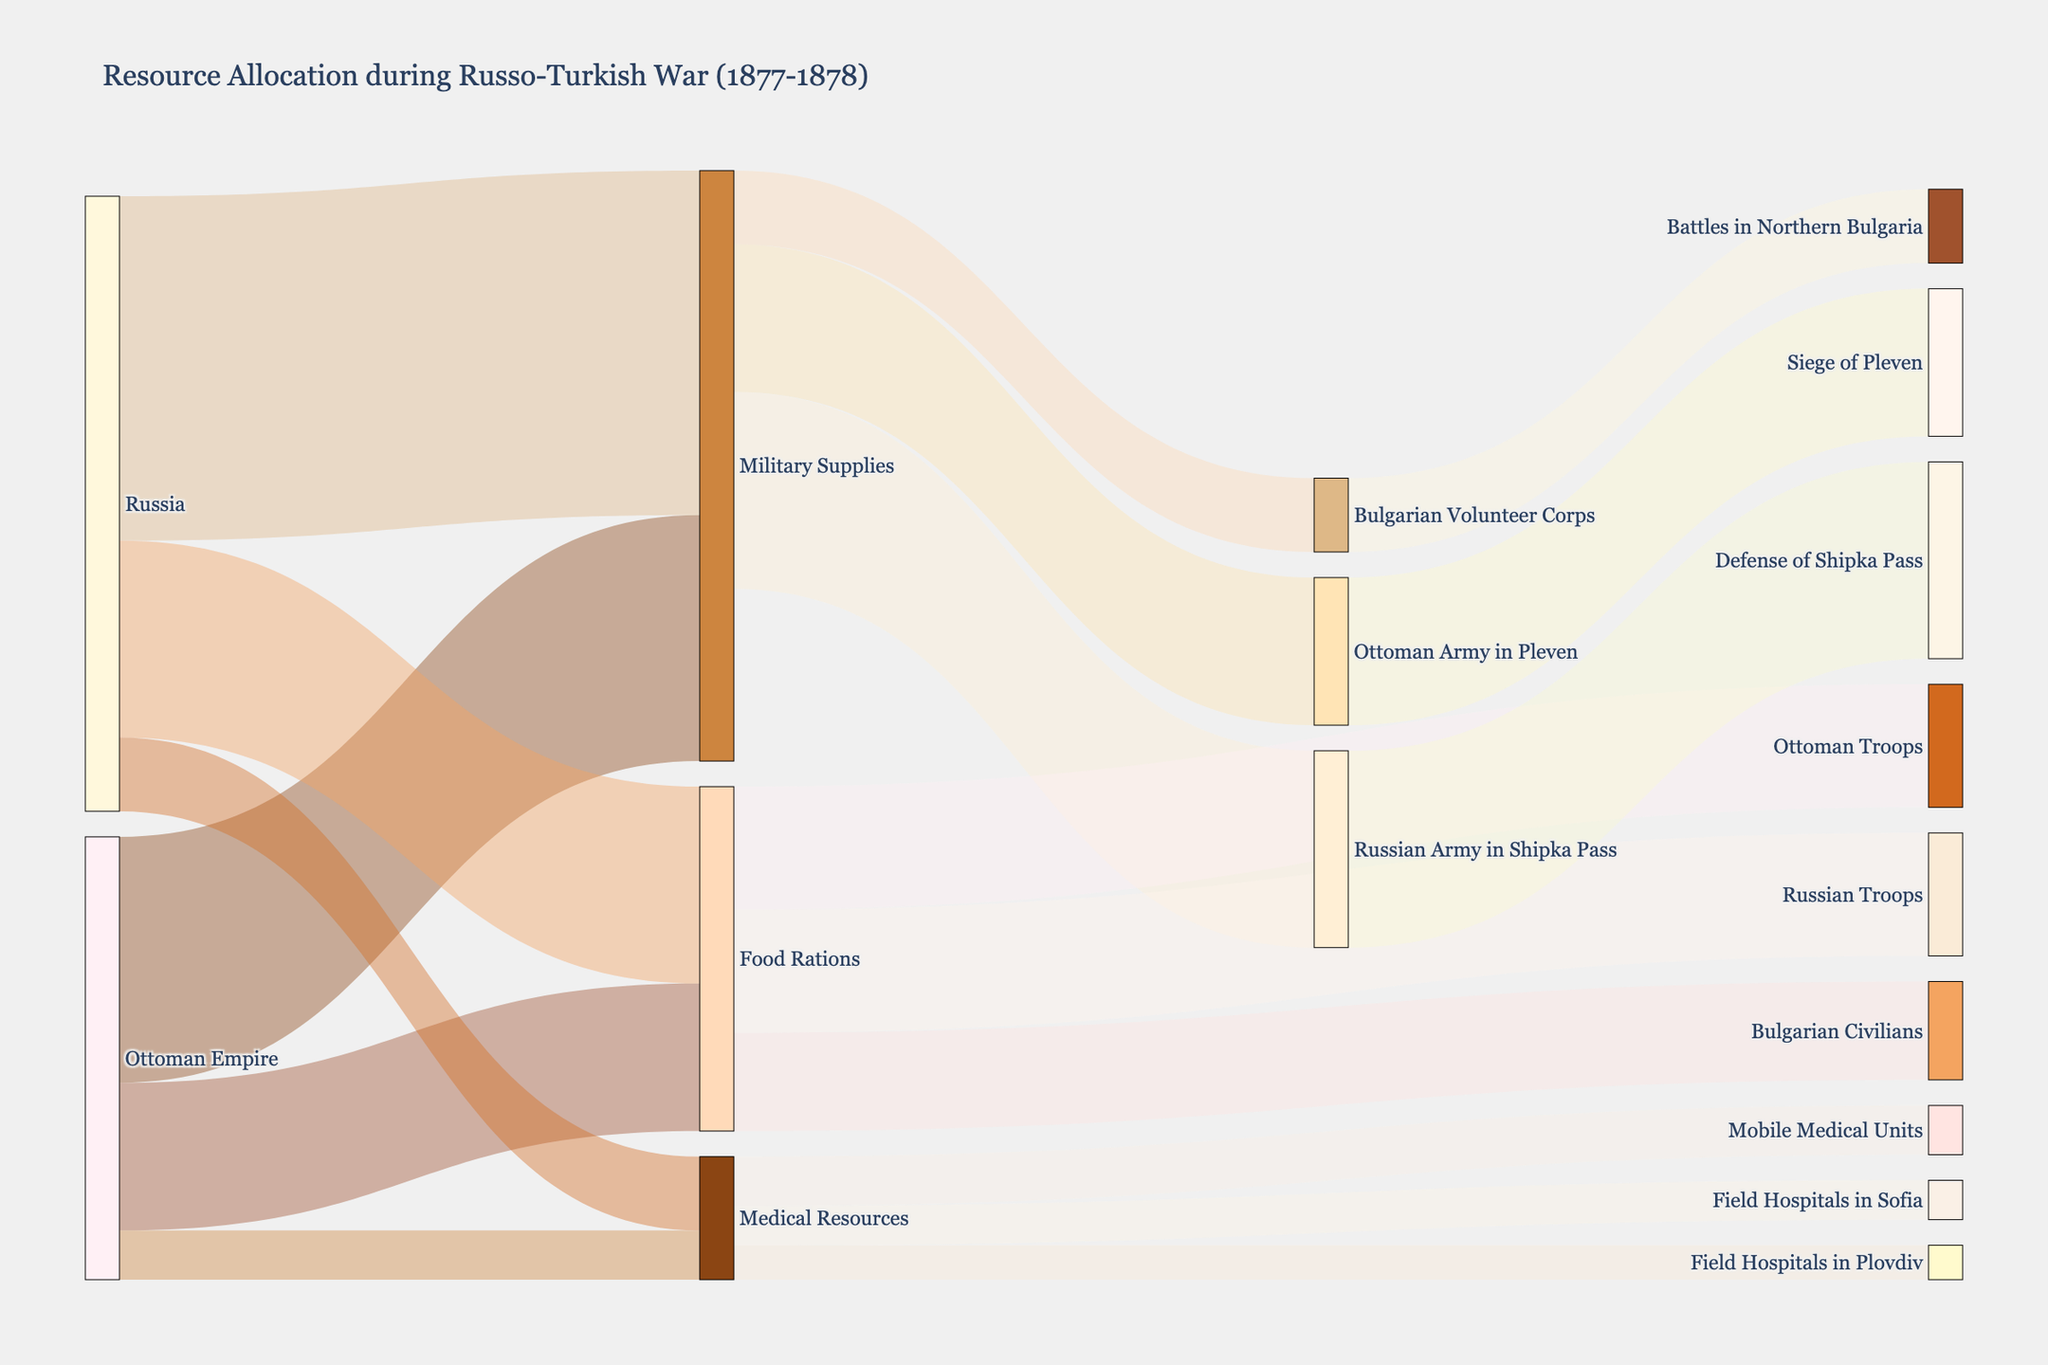What is the total amount of Military Supplies allocated by both the Ottoman Empire and Russia? Sum the value of Military Supplies from both the Ottoman Empire (50,000) and Russia (70,000): 50,000 + 70,000 = 120,000
Answer: 120,000 Which country allocated more Food Rations, and by how much? Compare the Food Rations allocated by the Ottoman Empire (30,000) and Russia (40,000); Russia allocated 40,000 - 30,000 = 10,000 more
Answer: Russia, 10,000 more How much Medical Resources were provided to the Field Hospitals in Bulgaria (Sofia and Plovdiv combined)? Add the Medical Resources values for Sofia (8,000) and Plovdiv (7,000): 8,000 + 7,000 = 15,000
Answer: 15,000 What were the primary destinations for the Military Supplies provided by the Ottoman Empire and Russia? The primary destinations for Military Supplies are the Bulgarian Volunteer Corps (15,000), the Ottoman Army in Pleven (30,000), and the Russian Army in Shipka Pass (40,000) as per their respective contributions
Answer: Bulgarian Volunteer Corps, Ottoman Army in Pleven, Russian Army in Shipka Pass Compare the amount of Military Supplies allocated to the Ottoman Army in Pleven and the Russian Army in Shipka Pass. Which received more and by what margin? The Ottoman Army in Pleven received 30,000 while the Russian Army in Shipka Pass received 40,000; the Russian Army received 40,000 - 30,000 = 10,000 more
Answer: Russian Army, 10,000 more How much Medical Resources were allocated to Mobile Medical Units? The figure shows that Mobile Medical Units received 10,000 in Medical Resources
Answer: 10,000 What was the distribution of Food Rations to military and civilian populations, and which received more? Food Rations were allocated as follows: Bulgarian Civilians (20,000), Ottoman Troops (25,000), Russian Troops (25,000); combined military (25,000 + 25,000 = 50,000) received more than civilians (20,000)
Answer: Military, 50,000; Civilians, 20,000 Which battles or sieges are associated with the Military Supplies allocations from the graph? The battles and sieges associated are the Siege of Pleven (30,000 for Ottoman Army in Pleven) and the Defense of Shipka Pass (40,000 for Russian Army in Shipka Pass), along with battles in Northern Bulgaria (15,000 for Bulgarian Volunteer Corps)
Answer: Siege of Pleven, Defense of Shipka Pass, Battles in Northern Bulgaria 